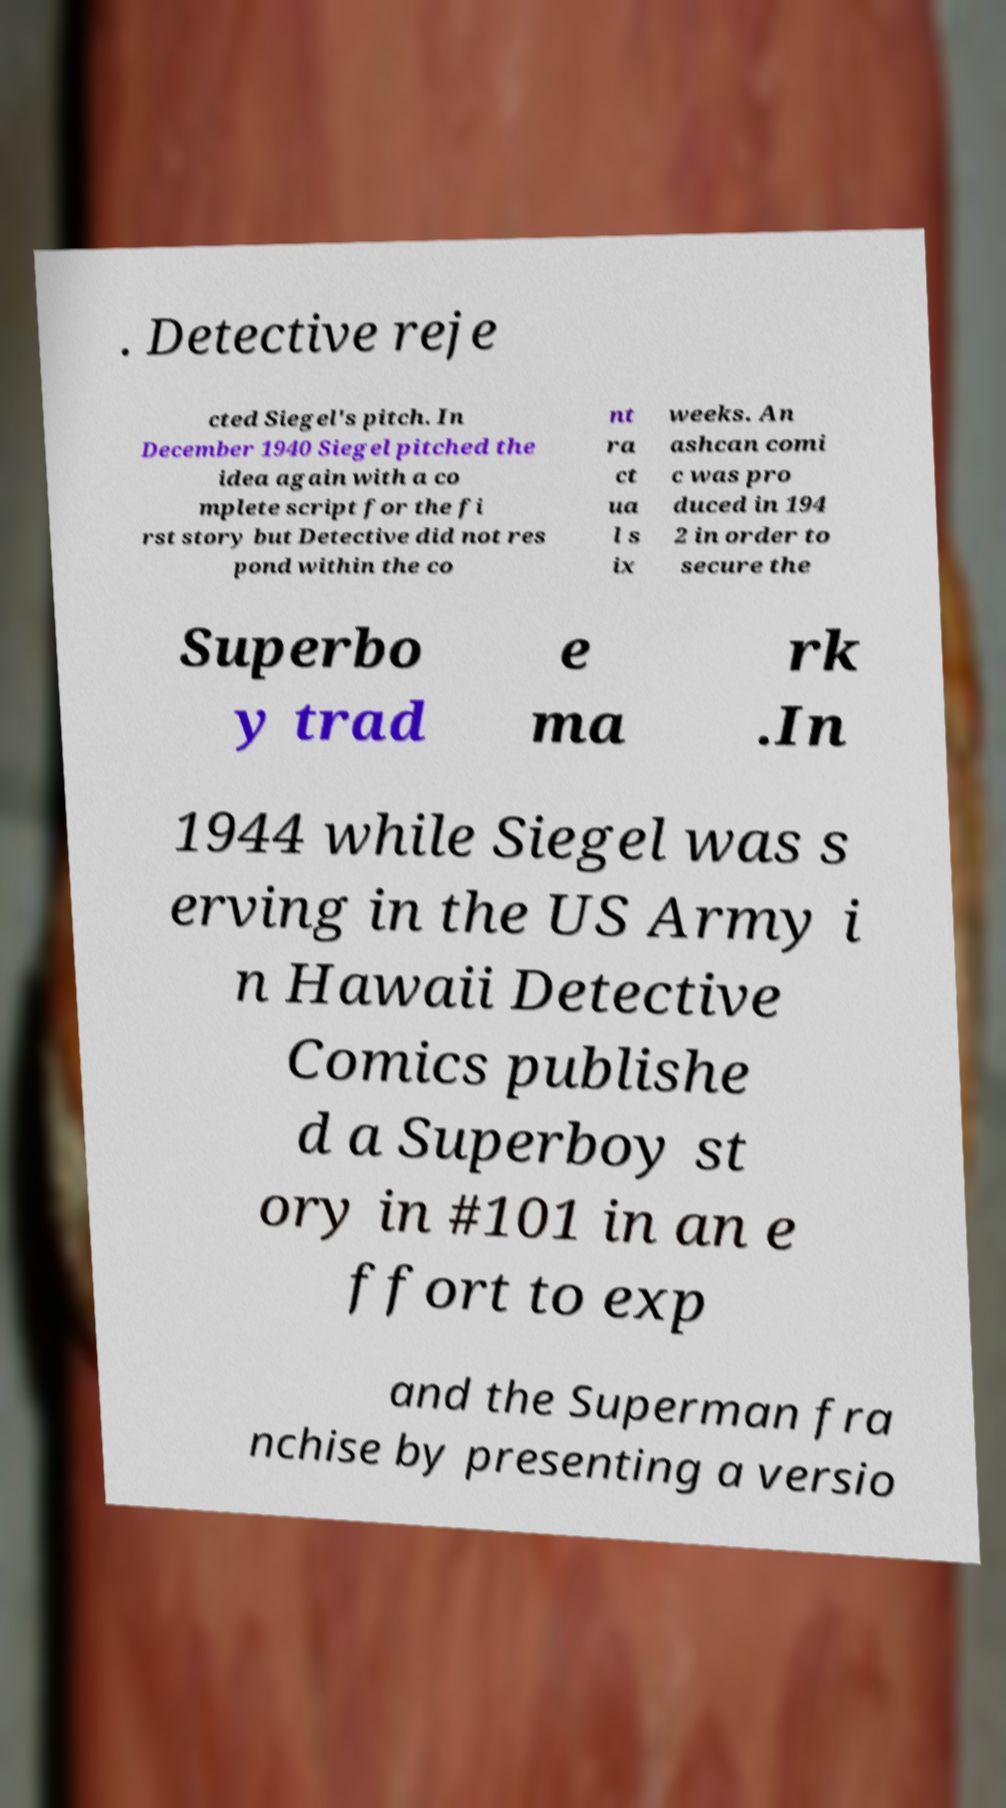Can you accurately transcribe the text from the provided image for me? . Detective reje cted Siegel's pitch. In December 1940 Siegel pitched the idea again with a co mplete script for the fi rst story but Detective did not res pond within the co nt ra ct ua l s ix weeks. An ashcan comi c was pro duced in 194 2 in order to secure the Superbo y trad e ma rk .In 1944 while Siegel was s erving in the US Army i n Hawaii Detective Comics publishe d a Superboy st ory in #101 in an e ffort to exp and the Superman fra nchise by presenting a versio 